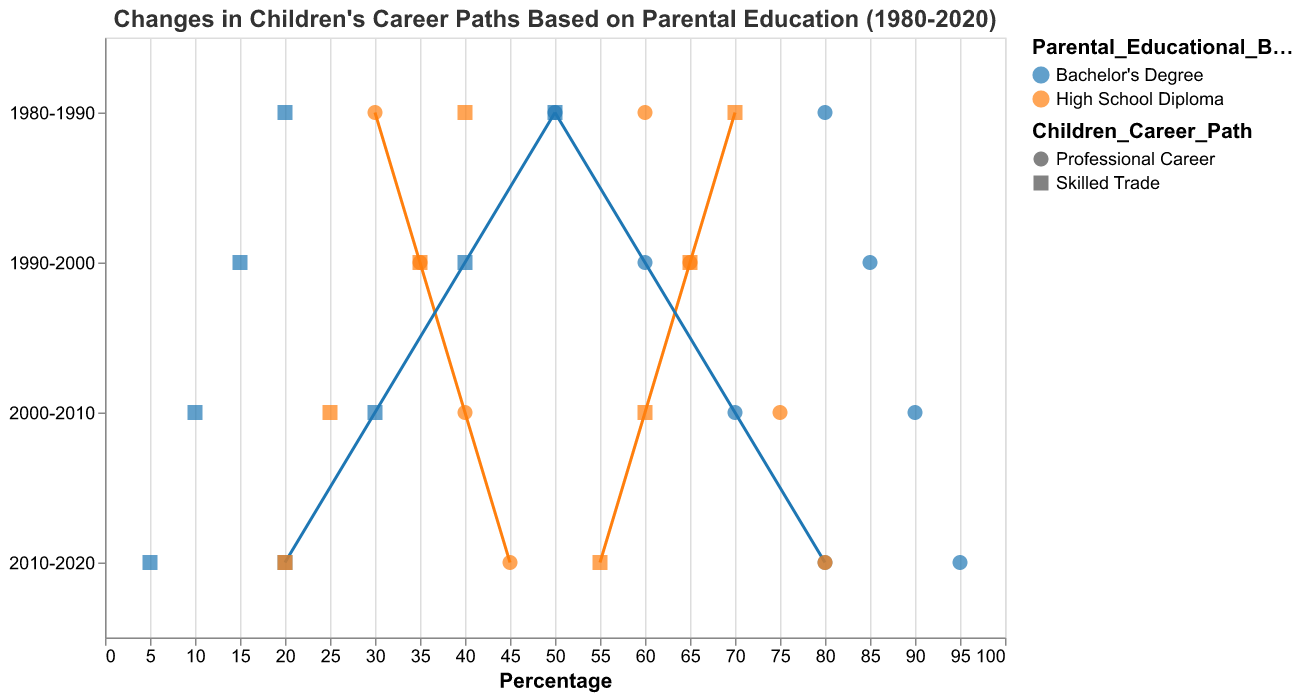What is the title of the figure? The title of the figure is displayed at the top and usually gives a summary of what the figure represents.
Answer: Changes in Children's Career Paths Based on Parental Education (1980-2020) What does the y-axis represent? The y-axis typically represents the categorical variable in a dumbbell plot. Here, it indicates different decades.
Answer: Decades (1980-2020) What are the colors representing in this plot? Each color denotes a different level of parental educational background, differentiating between "High School Diploma" and "Bachelor's Degree."
Answer: Parental Educational Background Which career path had a larger increase for children with parents holding a High School Diploma from 1980-2020? By comparing the plot points for children with parents with a High School Diploma, we observe changes in both skilled trade and professional career paths. The professional career path shows a more significant increase (from 30% to 80%).
Answer: Professional Career Compare the change in the percentage of children entering skilled trade jobs for parents with a Bachelor's Degree between 1980-1990 and 2000-2010. For 1980-1990, the skilled trade percentage went from 50% to 20% (change = -30%). From 2000-2010, it shifted from 30% to 10% (change = -20%).
Answer: -30% vs -20% What trend can be observed in children of parents with a High School Diploma entering skilled trades over the decades? By looking at each decade in the dumbbell plot, we see a consistent decline in the percentage: 70% to 55%.
Answer: Decline In which decade did children of parents with a Bachelor's Degree reach their lowest percentage in skilled trades? By checking the values for children in skilled trades across all decades, the lowest percentage was seen in 2010-2020.
Answer: 2010-2020 (5%) Which parental educational background led to a higher percentage of children pursuing professional careers in 2000-2010? Comparing the plot points, a Bachelor's Degree background resulted in a consistently higher percentage for professional careers.
Answer: Bachelor's Degree What was the percentage difference in children with a High School Diploma background entering professional careers between the decades 1980-1990 and 2010-2020? For 1980-1990, the percentage was 30%, and for 2010-2020, it was 80%; the difference is 80% - 30%.
Answer: 50% What is the overall trend in children's career paths based on parents' highest level of education observed over the three decades? Observing the entire dataset, children with higher parental education (Bachelor's Degree) more often pursue professional careers, while those with a High School Diploma increasingly move towards professional careers, but more slowly.
Answer: Increasing preference for professional careers 